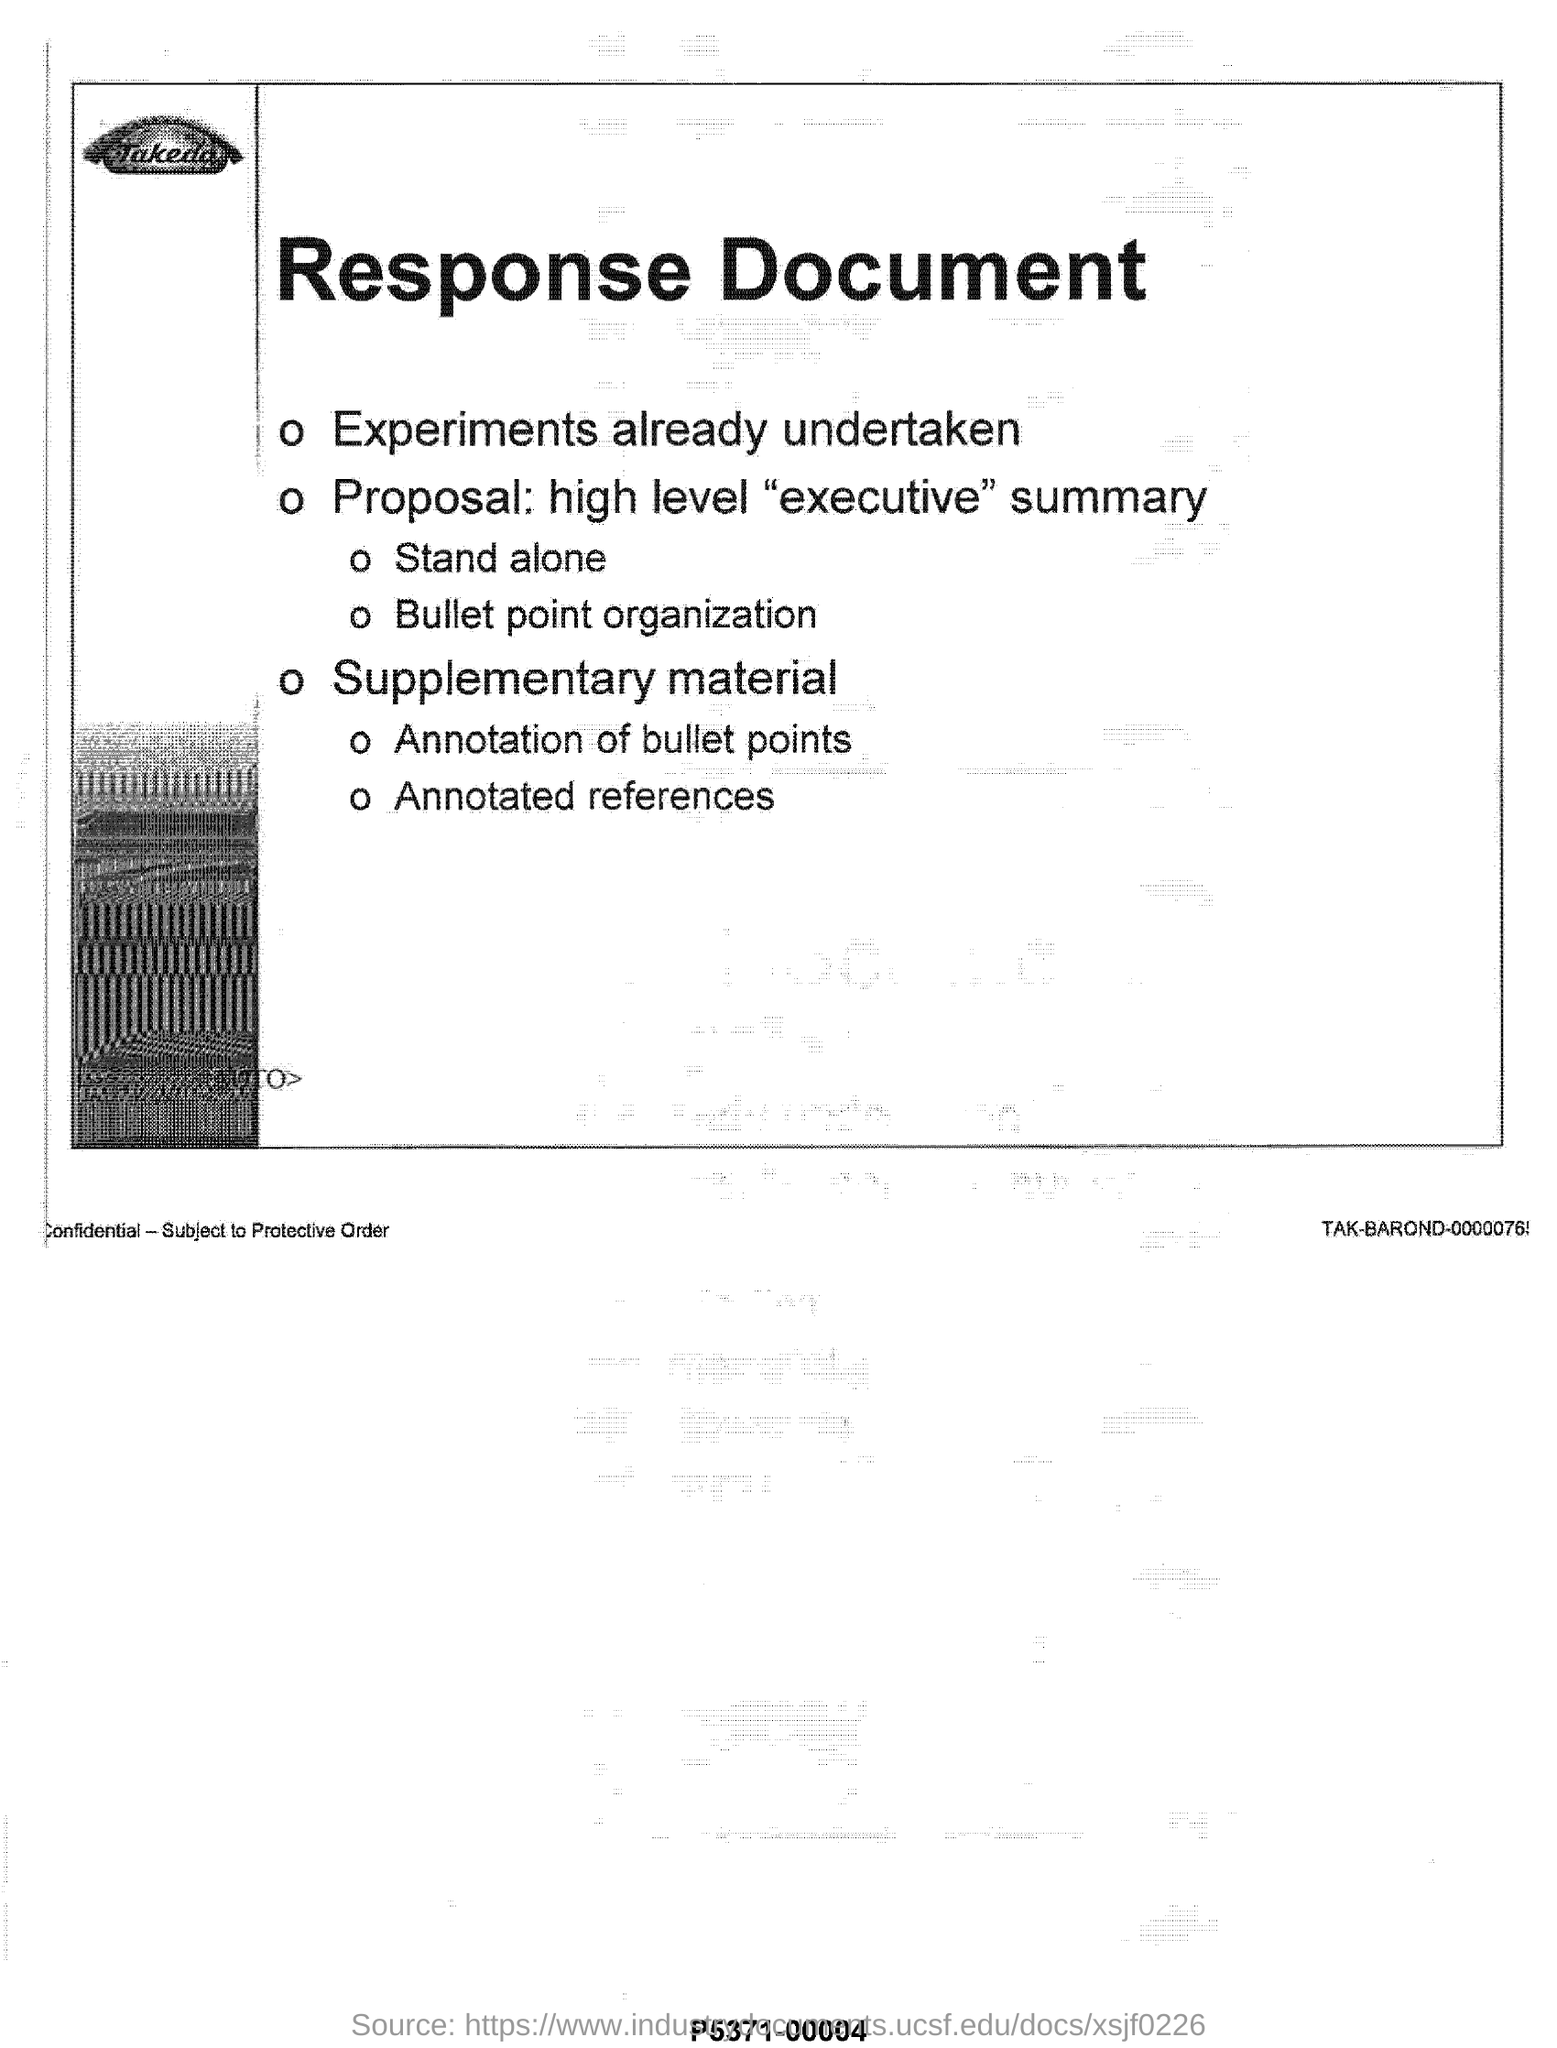Heading of the document?
Give a very brief answer. Response Document. 